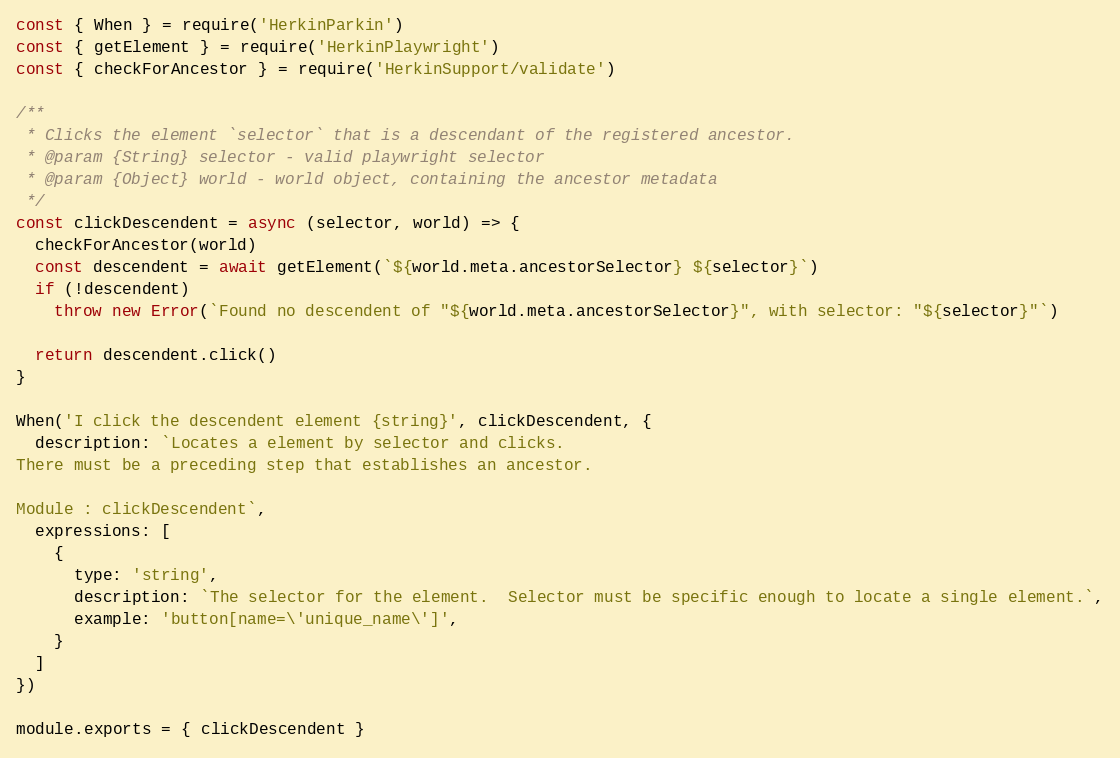<code> <loc_0><loc_0><loc_500><loc_500><_JavaScript_>const { When } = require('HerkinParkin')
const { getElement } = require('HerkinPlaywright')
const { checkForAncestor } = require('HerkinSupport/validate')

/**
 * Clicks the element `selector` that is a descendant of the registered ancestor.
 * @param {String} selector - valid playwright selector
 * @param {Object} world - world object, containing the ancestor metadata
 */
const clickDescendent = async (selector, world) => {
  checkForAncestor(world)
  const descendent = await getElement(`${world.meta.ancestorSelector} ${selector}`)
  if (!descendent)
    throw new Error(`Found no descendent of "${world.meta.ancestorSelector}", with selector: "${selector}"`)

  return descendent.click()
}

When('I click the descendent element {string}', clickDescendent, {
  description: `Locates a element by selector and clicks.
There must be a preceding step that establishes an ancestor.
  
Module : clickDescendent`,
  expressions: [
    {
      type: 'string',
      description: `The selector for the element.  Selector must be specific enough to locate a single element.`,
      example: 'button[name=\'unique_name\']',
    }
  ]
})

module.exports = { clickDescendent }
</code> 